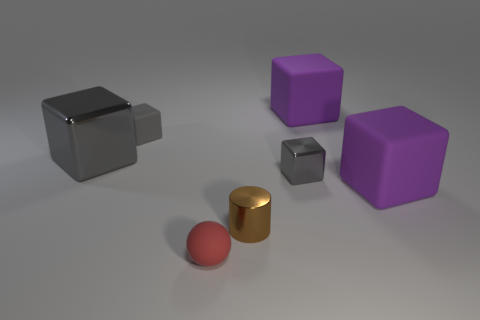What number of other objects are the same color as the big metallic cube?
Offer a very short reply. 2. There is a gray object that is the same material as the small red object; what is its size?
Ensure brevity in your answer.  Small. Do the tiny metallic cylinder and the tiny matte object that is to the left of the small red matte ball have the same color?
Provide a short and direct response. No. There is a object that is both behind the big shiny cube and right of the red rubber sphere; what is its material?
Keep it short and to the point. Rubber. The shiny thing that is the same color as the big shiny block is what size?
Offer a terse response. Small. There is a gray metallic object in front of the big gray metallic block; does it have the same shape as the tiny rubber thing in front of the small shiny cylinder?
Offer a terse response. No. Is there a large green matte ball?
Offer a very short reply. No. What is the color of the other small object that is the same shape as the tiny gray rubber object?
Offer a terse response. Gray. There is a metallic block that is the same size as the matte sphere; what is its color?
Offer a very short reply. Gray. Does the cylinder have the same material as the red object?
Keep it short and to the point. No. 